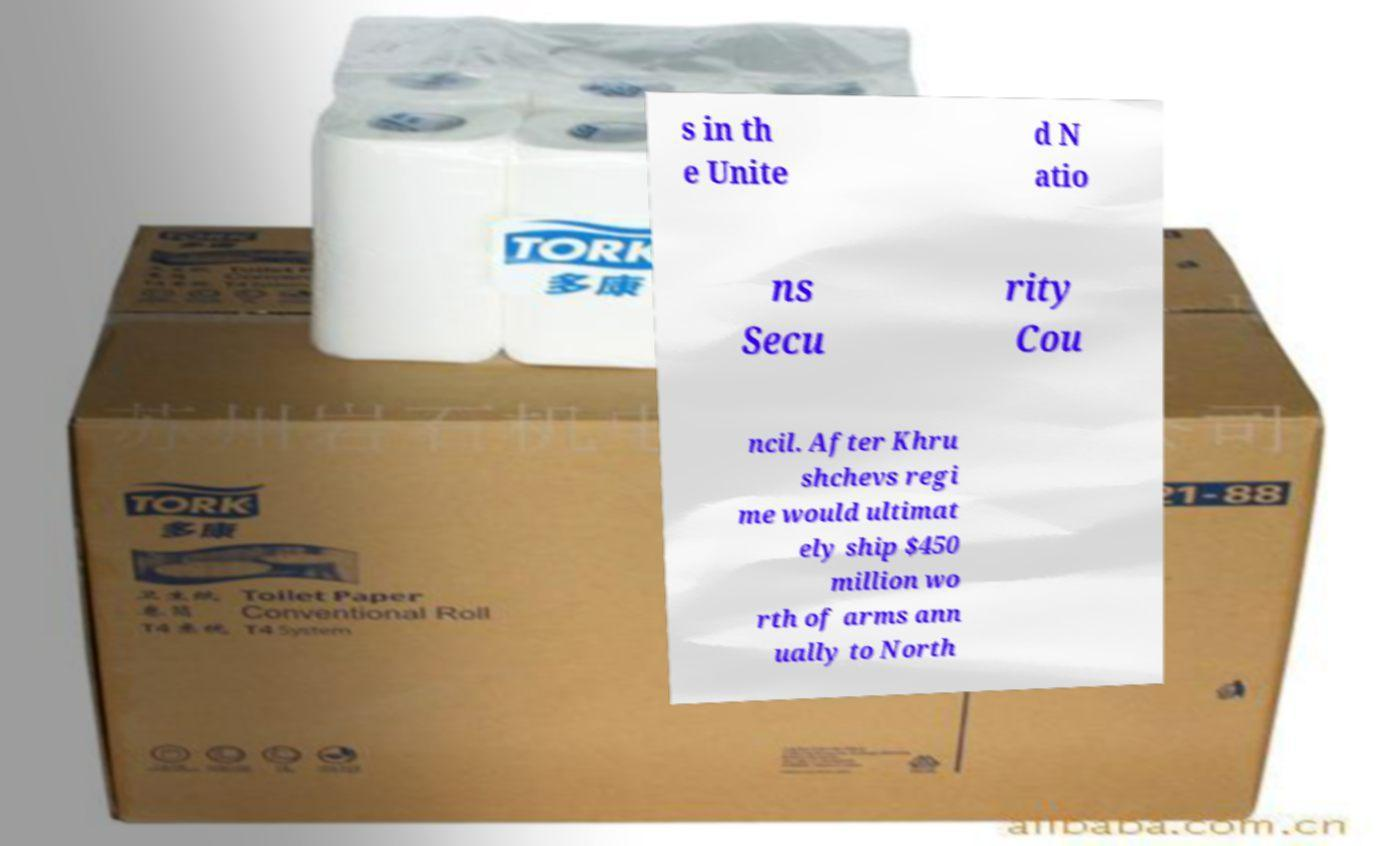Could you extract and type out the text from this image? s in th e Unite d N atio ns Secu rity Cou ncil. After Khru shchevs regi me would ultimat ely ship $450 million wo rth of arms ann ually to North 